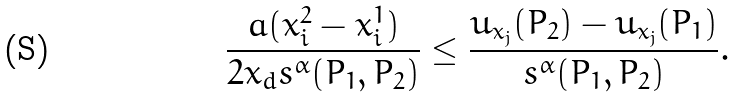Convert formula to latex. <formula><loc_0><loc_0><loc_500><loc_500>\frac { a ( x _ { i } ^ { 2 } - x _ { i } ^ { 1 } ) } { 2 x _ { d } s ^ { \alpha } ( P _ { 1 } , P _ { 2 } ) } \leq \frac { u _ { x _ { j } } ( P _ { 2 } ) - u _ { x _ { j } } ( P _ { 1 } ) } { s ^ { \alpha } ( P _ { 1 } , P _ { 2 } ) } .</formula> 